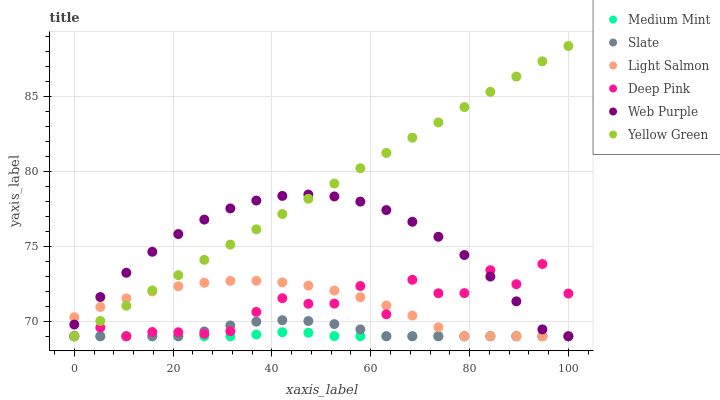Does Medium Mint have the minimum area under the curve?
Answer yes or no. Yes. Does Yellow Green have the maximum area under the curve?
Answer yes or no. Yes. Does Light Salmon have the minimum area under the curve?
Answer yes or no. No. Does Light Salmon have the maximum area under the curve?
Answer yes or no. No. Is Yellow Green the smoothest?
Answer yes or no. Yes. Is Deep Pink the roughest?
Answer yes or no. Yes. Is Light Salmon the smoothest?
Answer yes or no. No. Is Light Salmon the roughest?
Answer yes or no. No. Does Medium Mint have the lowest value?
Answer yes or no. Yes. Does Yellow Green have the highest value?
Answer yes or no. Yes. Does Light Salmon have the highest value?
Answer yes or no. No. Does Deep Pink intersect Medium Mint?
Answer yes or no. Yes. Is Deep Pink less than Medium Mint?
Answer yes or no. No. Is Deep Pink greater than Medium Mint?
Answer yes or no. No. 